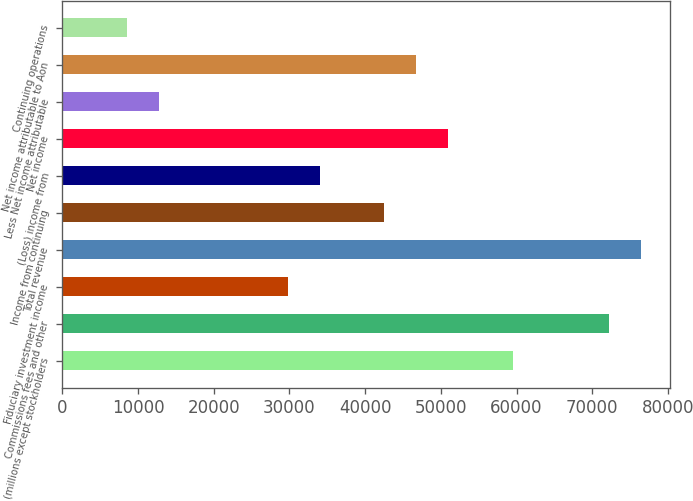<chart> <loc_0><loc_0><loc_500><loc_500><bar_chart><fcel>(millions except stockholders<fcel>Commissions fees and other<fcel>Fiduciary investment income<fcel>Total revenue<fcel>Income from continuing<fcel>(Loss) income from<fcel>Net income<fcel>Less Net income attributable<fcel>Net income attributable to Aon<fcel>Continuing operations<nl><fcel>59499.8<fcel>72249.6<fcel>29750.2<fcel>76499.5<fcel>42500<fcel>34000.1<fcel>50999.9<fcel>12750.4<fcel>46749.9<fcel>8500.48<nl></chart> 